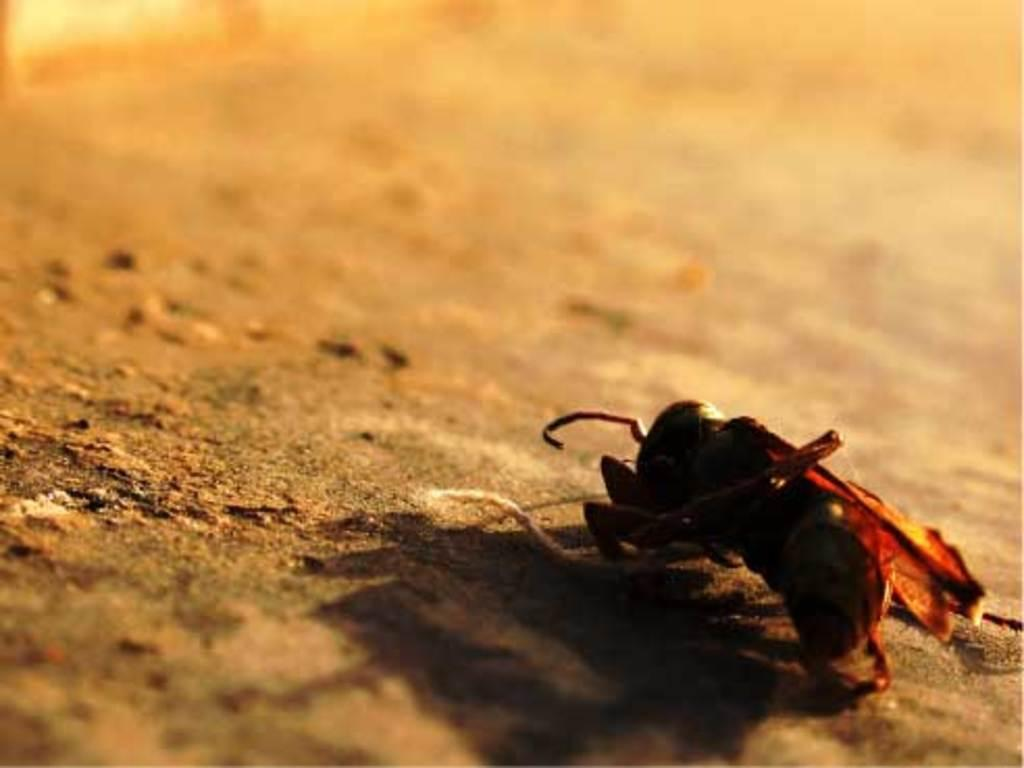What type of creature can be seen in the image? There is a small insect in the image. Where is the insect located in the image? The insect is on the ground. What type of expansion is the insect overseeing in the image? There is no indication of any expansion in the image, as it features a small insect on the ground. 